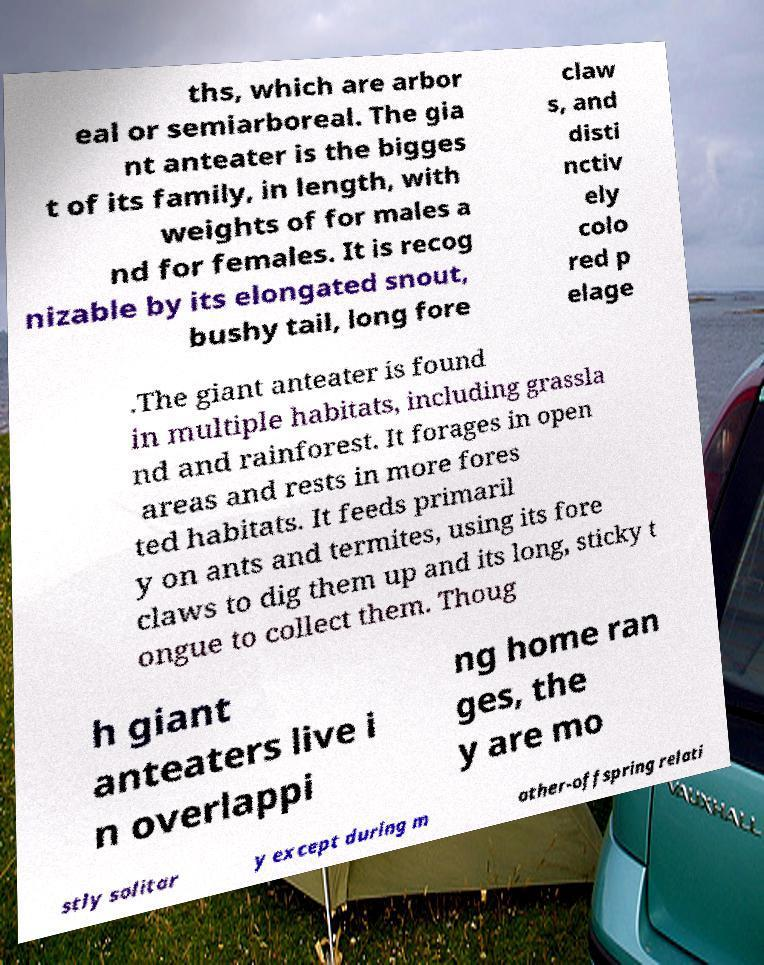Can you read and provide the text displayed in the image?This photo seems to have some interesting text. Can you extract and type it out for me? ths, which are arbor eal or semiarboreal. The gia nt anteater is the bigges t of its family, in length, with weights of for males a nd for females. It is recog nizable by its elongated snout, bushy tail, long fore claw s, and disti nctiv ely colo red p elage .The giant anteater is found in multiple habitats, including grassla nd and rainforest. It forages in open areas and rests in more fores ted habitats. It feeds primaril y on ants and termites, using its fore claws to dig them up and its long, sticky t ongue to collect them. Thoug h giant anteaters live i n overlappi ng home ran ges, the y are mo stly solitar y except during m other-offspring relati 